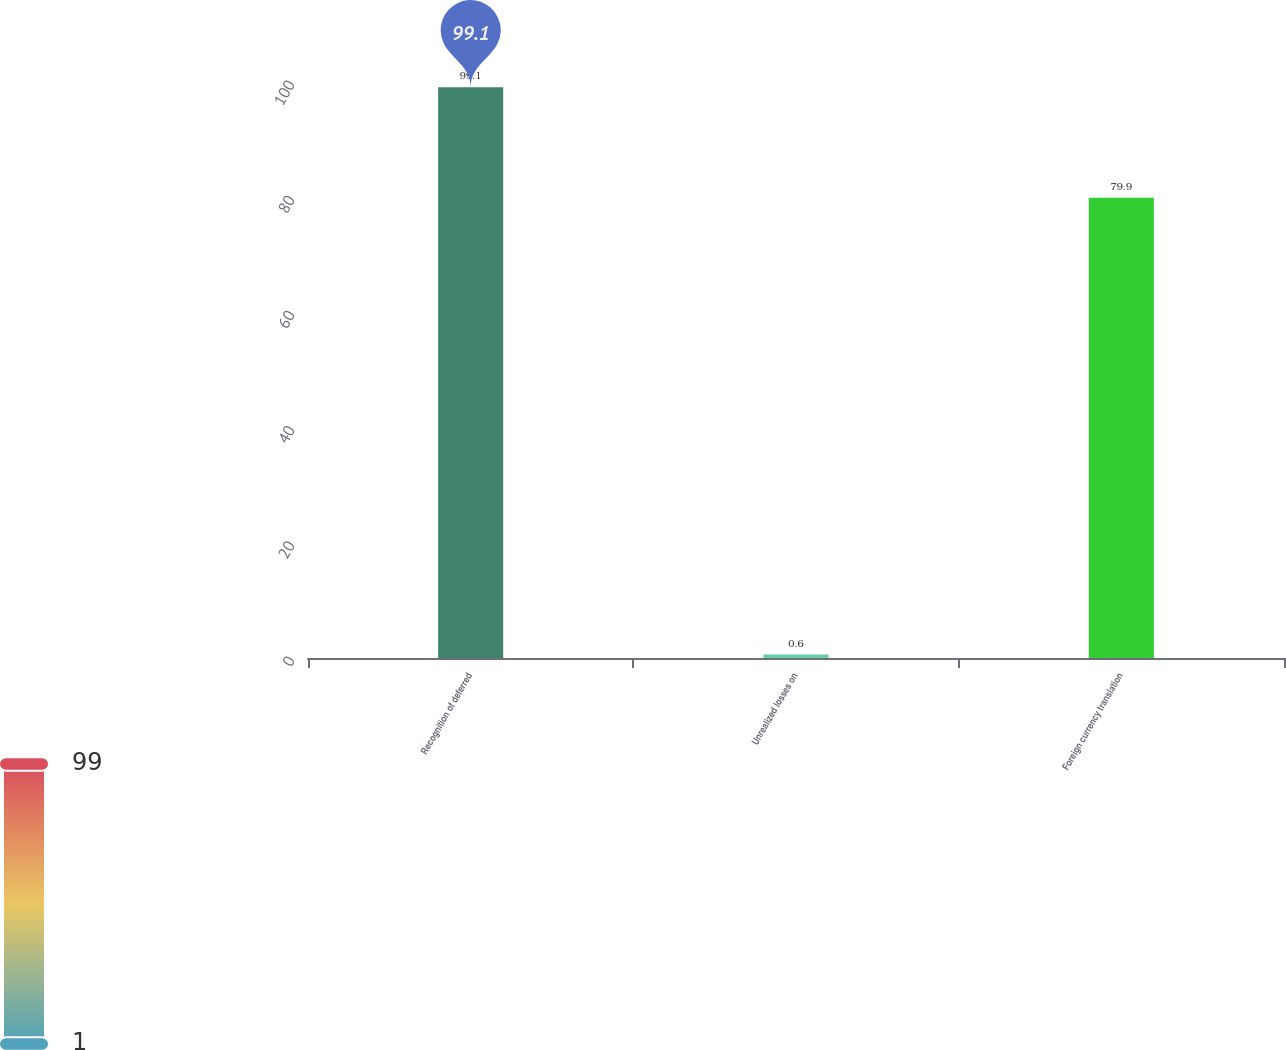<chart> <loc_0><loc_0><loc_500><loc_500><bar_chart><fcel>Recognition of deferred<fcel>Unrealized losses on<fcel>Foreign currency translation<nl><fcel>99.1<fcel>0.6<fcel>79.9<nl></chart> 